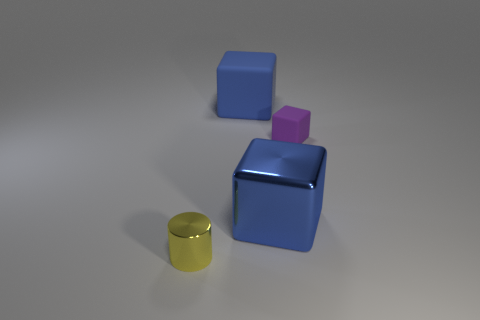What material is the tiny cylinder that is in front of the large cube that is in front of the blue object that is behind the small cube made of?
Your answer should be compact. Metal. Do the large blue object that is behind the tiny purple matte cube and the big blue object in front of the large blue matte thing have the same shape?
Provide a succinct answer. Yes. There is a small thing that is in front of the small object behind the tiny metallic object; what color is it?
Give a very brief answer. Yellow. There is a matte block behind the small object that is to the right of the yellow object; how many yellow shiny cylinders are to the right of it?
Keep it short and to the point. 0. The thing that is the same color as the large shiny cube is what size?
Make the answer very short. Large. Is the yellow object made of the same material as the small purple block?
Make the answer very short. No. There is a metallic object that is to the right of the large blue rubber thing; what number of large blue matte objects are behind it?
Your answer should be very brief. 1. What shape is the shiny thing behind the metallic thing left of the big blue thing that is behind the purple rubber cube?
Provide a short and direct response. Cube. There is a thing that is the same size as the yellow metal cylinder; what color is it?
Offer a very short reply. Purple. Is the size of the blue metal thing the same as the blue thing that is to the left of the large blue metallic block?
Provide a short and direct response. Yes. 